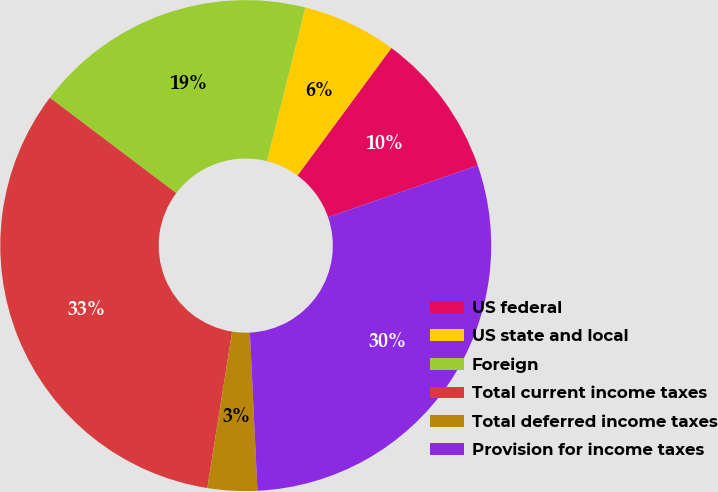Convert chart to OTSL. <chart><loc_0><loc_0><loc_500><loc_500><pie_chart><fcel>US federal<fcel>US state and local<fcel>Foreign<fcel>Total current income taxes<fcel>Total deferred income taxes<fcel>Provision for income taxes<nl><fcel>9.6%<fcel>6.21%<fcel>18.61%<fcel>32.79%<fcel>3.26%<fcel>29.53%<nl></chart> 